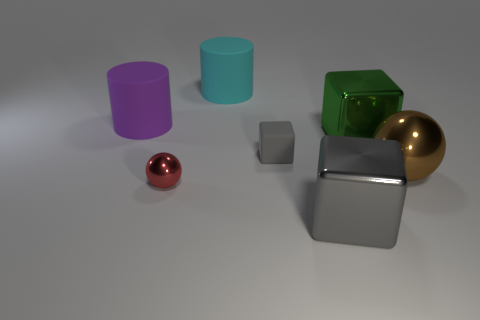Subtract all rubber blocks. How many blocks are left? 2 Subtract all brown cylinders. How many gray blocks are left? 2 Subtract all green cubes. How many cubes are left? 2 Subtract 1 cylinders. How many cylinders are left? 1 Subtract all red cubes. Subtract all brown cylinders. How many cubes are left? 3 Add 2 big brown balls. How many objects exist? 9 Subtract all cylinders. How many objects are left? 5 Subtract all metallic things. Subtract all tiny green matte spheres. How many objects are left? 3 Add 7 green objects. How many green objects are left? 8 Add 3 tiny cyan metal cylinders. How many tiny cyan metal cylinders exist? 3 